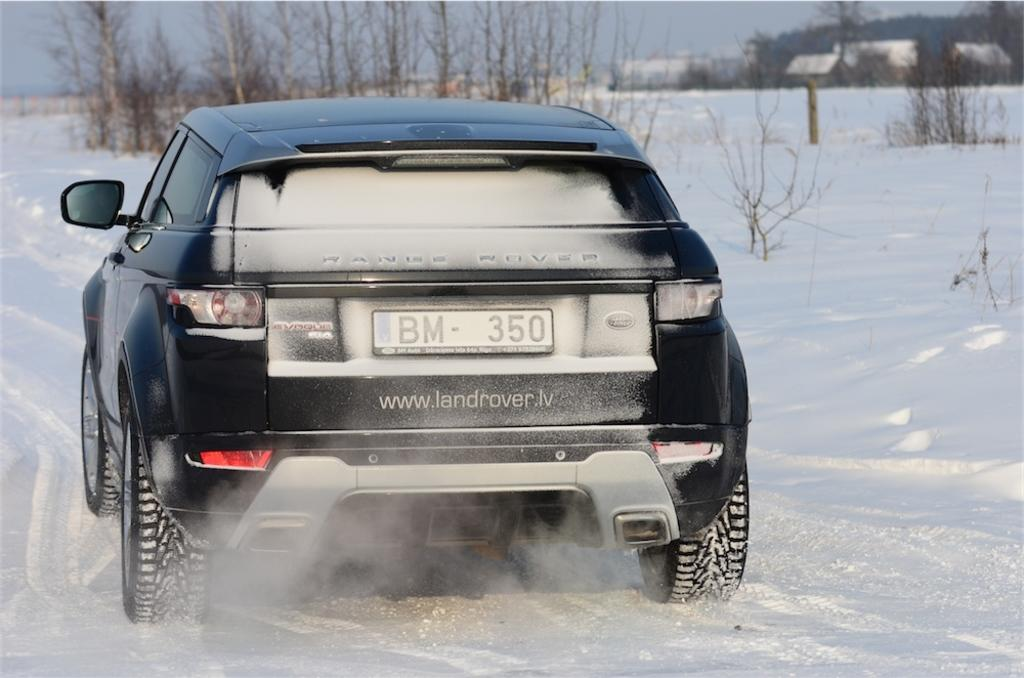<image>
Describe the image concisely. Black car with a license plate which says BM350. 